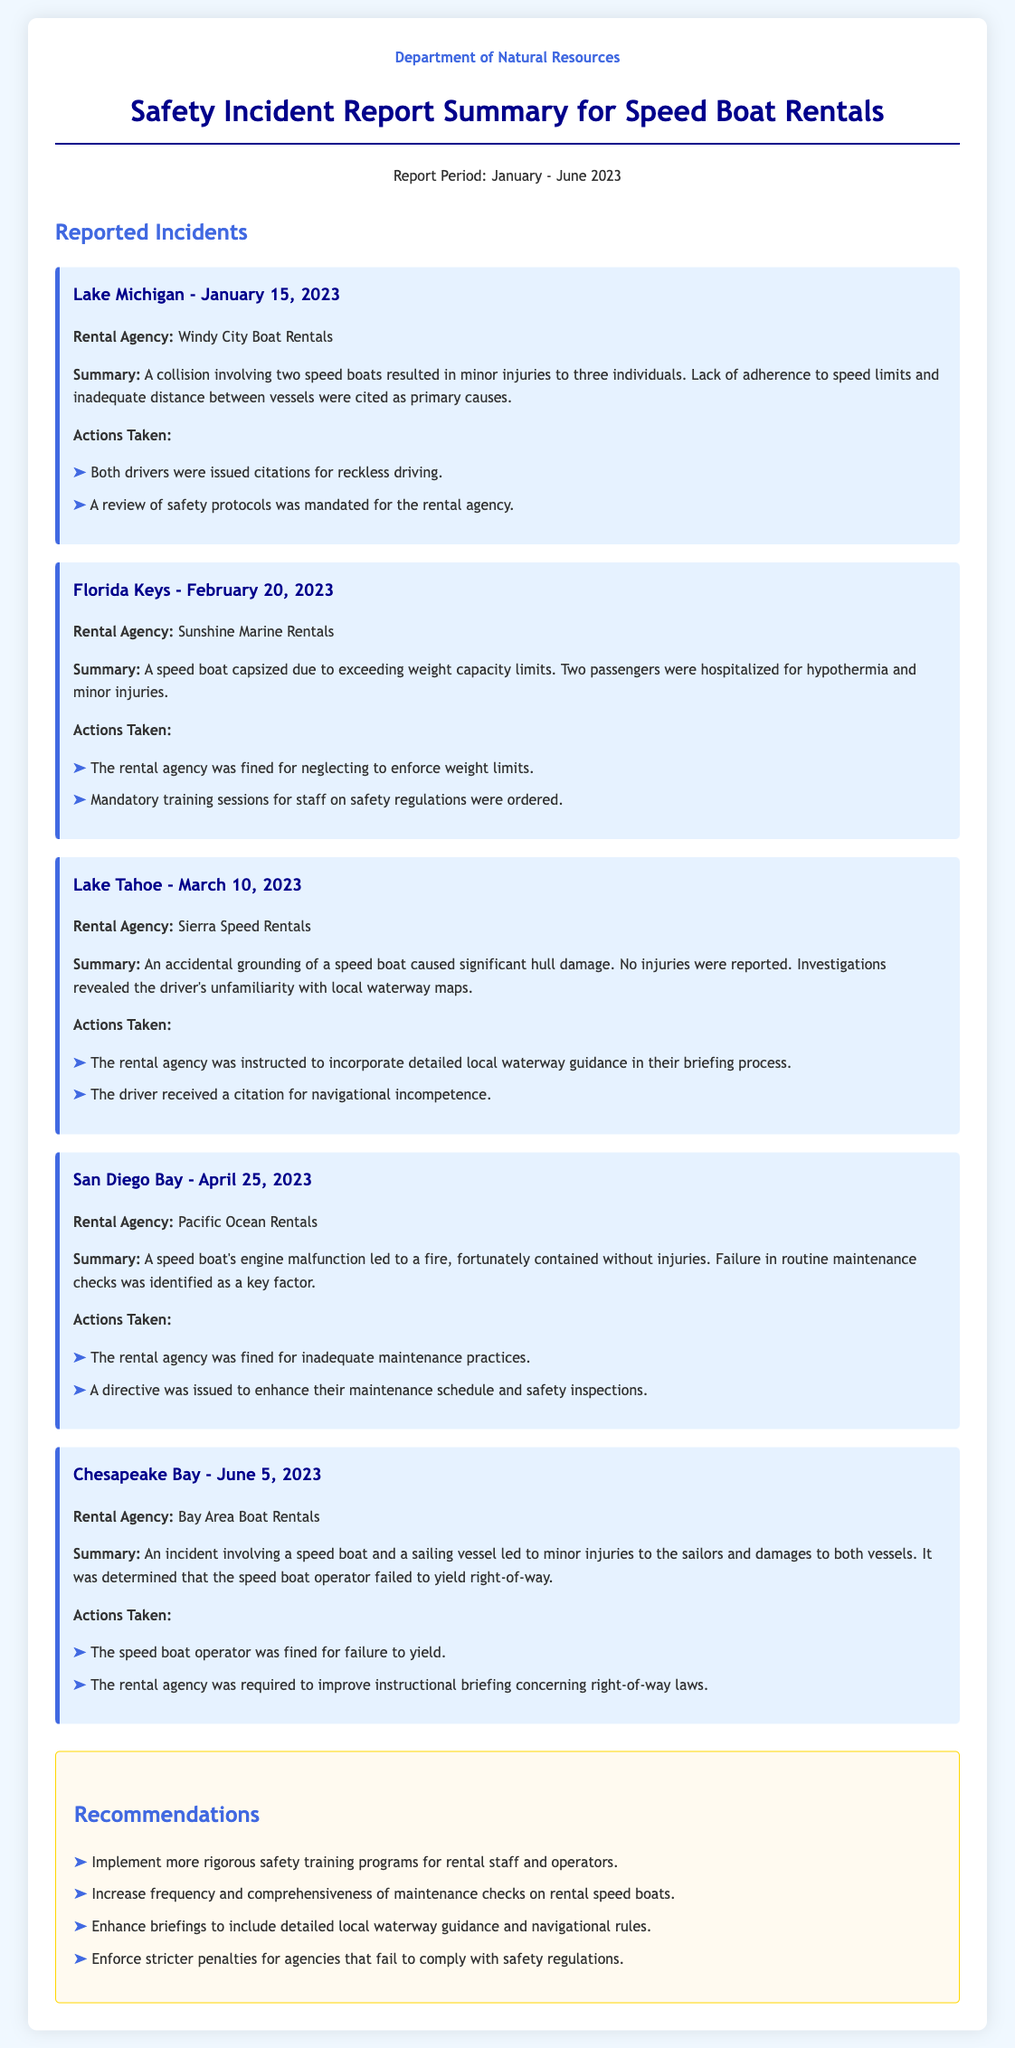what was the date of the incident in Lake Michigan? The incident in Lake Michigan occurred on January 15, 2023.
Answer: January 15, 2023 how many individuals were injured in the Lake Michigan incident? The incident involved minor injuries to three individuals.
Answer: three which rental agency was involved in the Florida Keys incident? The rental agency involved in the Florida Keys incident was Sunshine Marine Rentals.
Answer: Sunshine Marine Rentals what action was taken against the drivers involved in the Lake Michigan incident? Both drivers were issued citations for reckless driving.
Answer: citations for reckless driving what was a primary cause of the capsizing incident in the Florida Keys? The primary cause was exceeding weight capacity limits.
Answer: exceeding weight capacity limits how many recommendations are listed in the document? The document lists four recommendations in the recommendations section.
Answer: four which agency was fined for inadequate maintenance practices? The rental agency fined for inadequate maintenance practices was Pacific Ocean Rentals.
Answer: Pacific Ocean Rentals what was required to be improved in the briefing process for Sierra Speed Rentals? The company was instructed to incorporate detailed local waterway guidance in their briefing process.
Answer: detailed local waterway guidance 